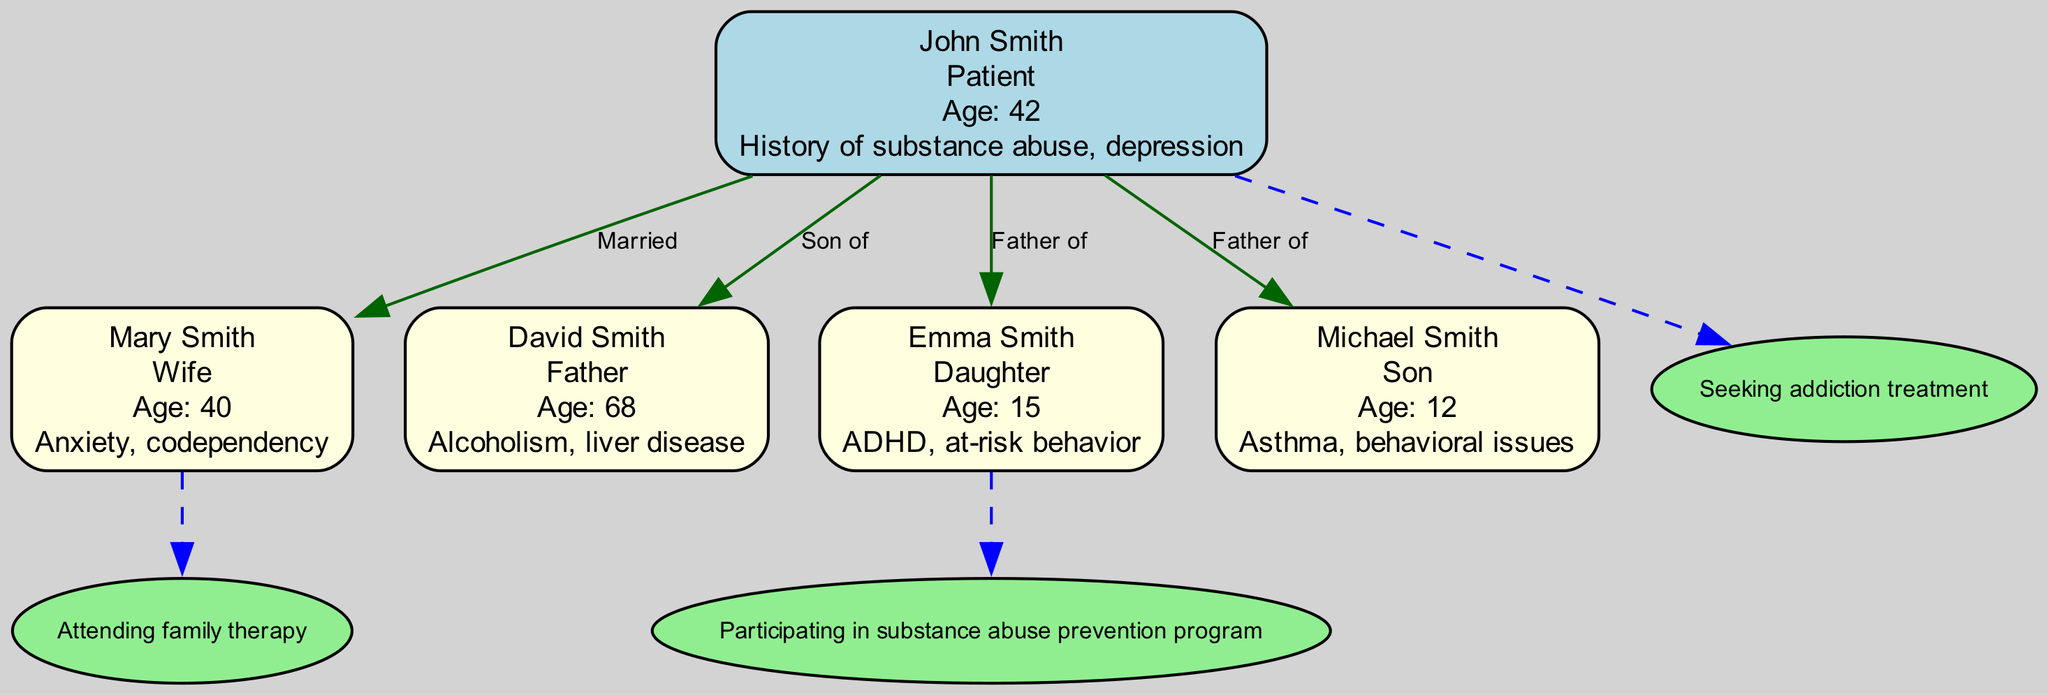What is John Smith's health condition? The diagram lists John Smith's health condition as "History of substance abuse, depression". This information is found in the relevant node representing John Smith in the family tree.
Answer: History of substance abuse, depression Who is Mary Smith's husband? By tracing the relationship from the node for Mary Smith, it is indicated that she is "Married" to John Smith, making him her husband.
Answer: John Smith How many children do John and Mary Smith have? The diagram indicates two nodes with arrows pointing from John Smith to both Emma Smith and Michael Smith labeled as "Father of", meaning they are his children. Thus, they have two children.
Answer: 2 What health behavior is Emma Smith participating in? The diagram shows a dashed edge from Emma Smith to the behavior node that states she is "Participating in substance abuse prevention program", which indicates her specific health behavior.
Answer: Participating in substance abuse prevention program Which family member has a health condition related to alcoholism? By reviewing the nodes, David Smith is identified with the health condition "Alcoholism, liver disease", making him the family member with this specific issue.
Answer: David Smith What is the relationship between John Smith and David Smith? In the diagram, there is an edge that states "Son of" from David Smith to John Smith, which indicates that John is the son of David. Thus, John Smith is the son of David Smith.
Answer: Son of Which family member is experiencing at-risk behavior? Referencing the health condition listed for Emma Smith, it states "ADHD, at-risk behavior", clearly identifying her as the family member experiencing this behavior.
Answer: Emma Smith How old is Michael Smith? The diagram indicates that Michael Smith's age is specified as 12, which can be found within his associated node.
Answer: 12 What health behavior is Mary Smith attending? The dashed edge from Mary Smith leads to the node indicating "Attending family therapy", making this her health behavior.
Answer: Attending family therapy 